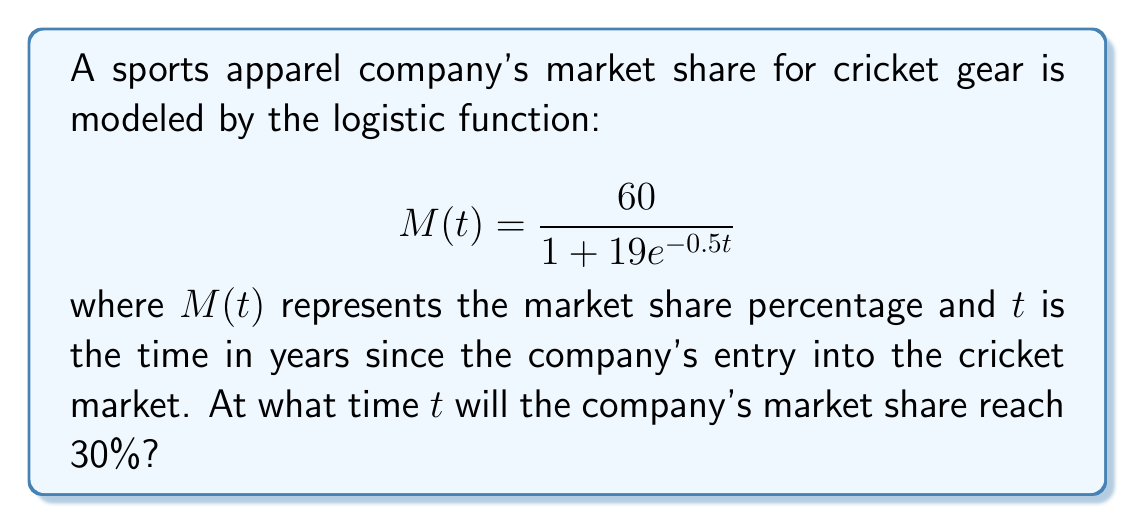Provide a solution to this math problem. To solve this problem, we need to follow these steps:

1) We want to find $t$ when $M(t) = 30$. So, we set up the equation:

   $$30 = \frac{60}{1 + 19e^{-0.5t}}$$

2) Multiply both sides by $(1 + 19e^{-0.5t})$:

   $$30(1 + 19e^{-0.5t}) = 60$$

3) Distribute on the left side:

   $$30 + 570e^{-0.5t} = 60$$

4) Subtract 30 from both sides:

   $$570e^{-0.5t} = 30$$

5) Divide both sides by 570:

   $$e^{-0.5t} = \frac{1}{19}$$

6) Take the natural log of both sides:

   $$-0.5t = \ln(\frac{1}{19})$$

7) Divide both sides by -0.5:

   $$t = -\frac{2}{1}\ln(\frac{1}{19}) = 2\ln(19)$$

8) Calculate the final value:

   $$t \approx 5.88$$

Therefore, the company's market share will reach 30% after approximately 5.88 years.
Answer: $2\ln(19) \approx 5.88$ years 